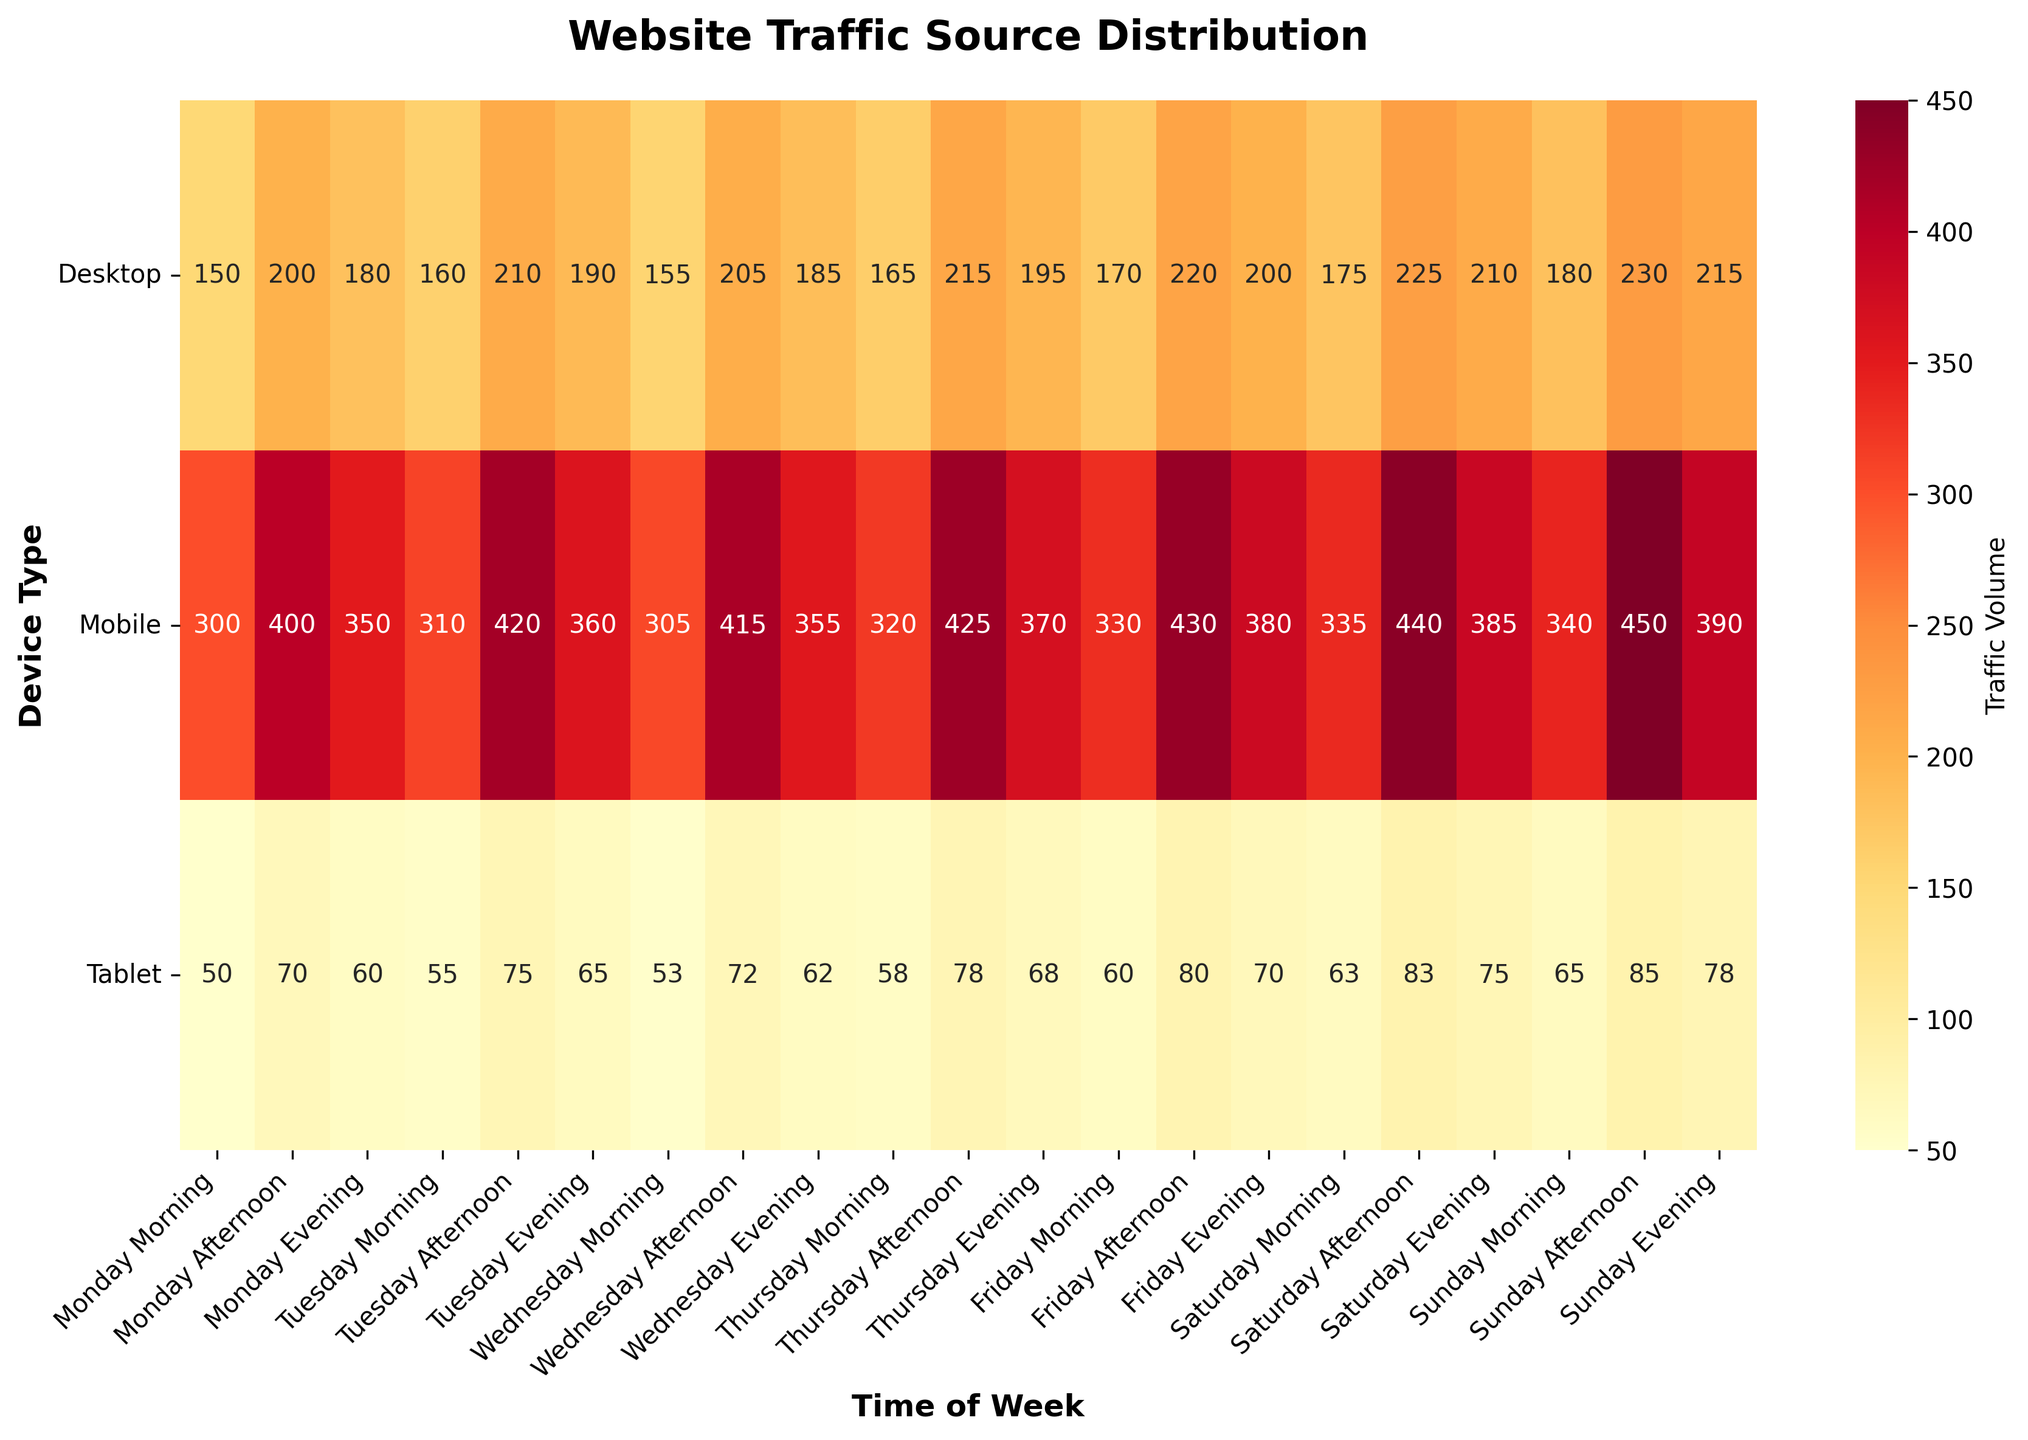What is the title of the heatmap? The title is usually located at the top of the plot. The title in this heatmap is quite descriptive about the data representation.
Answer: Website Traffic Source Distribution Which time slot shows the highest traffic volume for the Mobile device? By looking at the heatmap, identify the highest value in the Mobile row, which corresponds to Sunday Afternoon.
Answer: Sunday Afternoon How much more traffic does Tablet receive on Friday Evening compared to Wednesday Morning? First, find the values for Tablet on Friday Evening and Wednesday Morning, which are 70 and 53 respectively. Then calculate the difference: 70 - 53 = 17.
Answer: 17 Which day has the overall highest traffic across all devices for any time slot? Check each day and time slot combination to find the highest number across all devices. Sunday Afternoon has the highest traffic (450 on Mobile).
Answer: Sunday Is there more traffic on Desktop or Tablet on Saturday Morning? Compare the values for Desktop and Tablet in the Saturday Morning column, which are 175 and 63 respectively. Desktop traffic is higher.
Answer: Desktop What is the average traffic volume for Mobile on weekdays (Monday to Friday) during the Afternoon? Sum the Mobile weekday Afternoon traffic (400 + 420 + 415 + 425 + 430) and divide by 5. (400 + 420 + 415 + 425 + 430) / 5 = 418.
Answer: 418 Which device tends to have higher traffic overall across the week? Sum the traffic values for each device across all time slots and compare. It's visible that Mobile has the highest cumulative traffic.
Answer: Mobile What traffic volume does Tablet receive on Tuesday despite the afternoon? Look at the heatmap for Tablet's value on Tuesday Afternoon, which is 75.
Answer: 75 On which time slot does Desktop traffic surpass Mobile traffic? Compare each paired time slot for Desktop and Mobile. There is no time slot where Desktop traffic surpasses Mobile traffic in the given data.
Answer: None How much does traffic volume fluctuate for Desktop during the weekdays? Identify the minimum and maximum values for Desktop traffic during the weekdays (150 to 220). The fluctuation is calculated as 220 - 150 = 70.
Answer: 70 